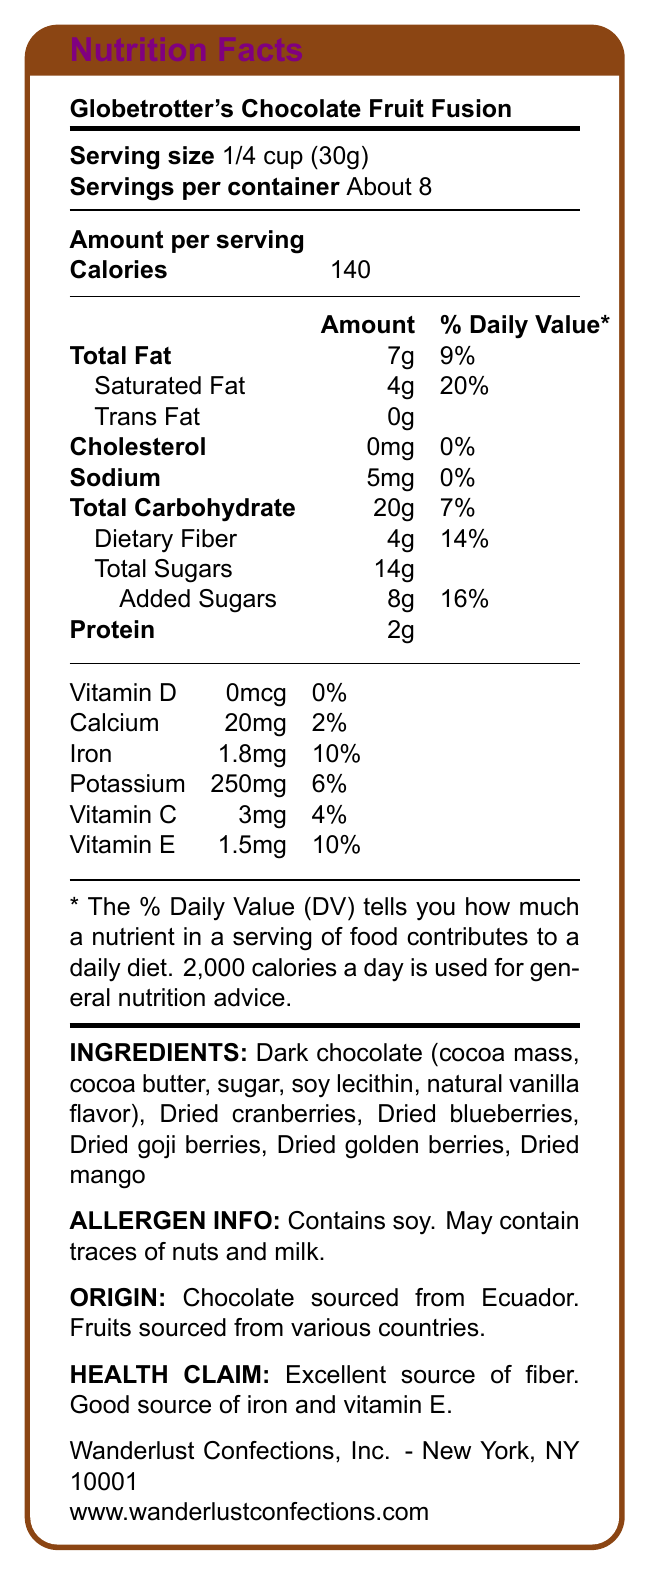What is the serving size of Globetrotter's Chocolate Fruit Fusion? The serving size is clearly mentioned at the top of the document as "Serving size 1/4 cup (30g)".
Answer: 1/4 cup (30g) How many servings are there in the container? The number of servings per container is listed as "About 8" right below the serving size.
Answer: About 8 What is the total dietary fiber per serving? Under the Total Carbohydrate section, the document specifies "Dietary Fiber 4g".
Answer: 4g How much Vitamin E is there in a serving? The nutrients section shows "Vitamin E 1.5mg".
Answer: 1.5mg How many calories does each serving contain? The calories per serving are listed as "Calories 140" in the Amount per Serving section.
Answer: 140 Which of the following nutrients can you find 10% of the daily value for in a serving? A. Calcium B. Iron C. Vitamin D D. Potassium According to the document, Iron has a % Daily Value of 10%.
Answer: B. Iron Where is the chocolate in this product sourced from? A. New York B. Ecuador C. Belgium D. Switzerland The origin statement mentions that "Chocolate sourced from Ecuador".
Answer: B. Ecuador Is Globetrotter's Chocolate Fruit Fusion a good source of Vitamin D? The document shows 0% daily value for Vitamin D, indicating it's not a good source.
Answer: No Summarize the main nutritional properties emphasized for Globetrotter's Chocolate Fruit Fusion. The document emphasizes that the product is an excellent source of fiber and also a good source of iron and Vitamin E, which are noted in the health claim section.
Answer: The product is highlighted as an excellent source of fiber and a good source of iron and Vitamin E. It has 140 calories per serving, with 4g of dietary fiber and significant amounts of iron and Vitamin E. What is the amount of added sugars per serving? The document lists "Added Sugars 8g" under the Total Sugars section.
Answer: 8g How much potassium does one serving contain? The nutrient section lists "Potassium 250mg".
Answer: 250mg Can someone with a soy allergy consume this product? The allergen information states that the product contains soy.
Answer: No How much saturated fat is in one serving? The document specifies "Saturated Fat 4g" under the Total Fat section.
Answer: 4g Which ingredient is not explicitly listed in the ingredients section? A. Dried cranberries B. Dried blueberries C. Chia seeds D. Dried goji berries Chia seeds are not listed among the ingredients.
Answer: C. Chia seeds What is the main company behind Globetrotter's Chocolate Fruit Fusion? The company information at the bottom of the document states "Wanderlust Confections, Inc. - New York, NY 10001".
Answer: Wanderlust Confections, Inc. How much iron does the product provide as a percentage of daily value? The % Daily Value for iron is listed as 10%.
Answer: 10% What other allergens might be present in the product aside from soy? The allergen information says that it may contain traces of nuts and milk.
Answer: Nuts and milk What is the carbohydrate content per serving? The Total Carbohydrate amount is given as "20g".
Answer: 20g What is the daily value percentage for calcium in one serving? The nutrient section lists "Calcium 20mg" with a daily value of 2%.
Answer: 2% What is the website for Wanderlust Confections, Inc.? The document provides the website at the bottom: "www.wanderlustconfections.com".
Answer: www.wanderlustconfections.com What is the main health claim made about this product? The health claim section states: "Excellent source of fiber. Good source of iron and vitamin E."
Answer: Excellent source of fiber. Good source of iron and vitamin E. Can you determine the price of Globetrotter's Chocolate Fruit Fusion from the document? The document does not provide any information regarding the price of the product.
Answer: Not enough information 